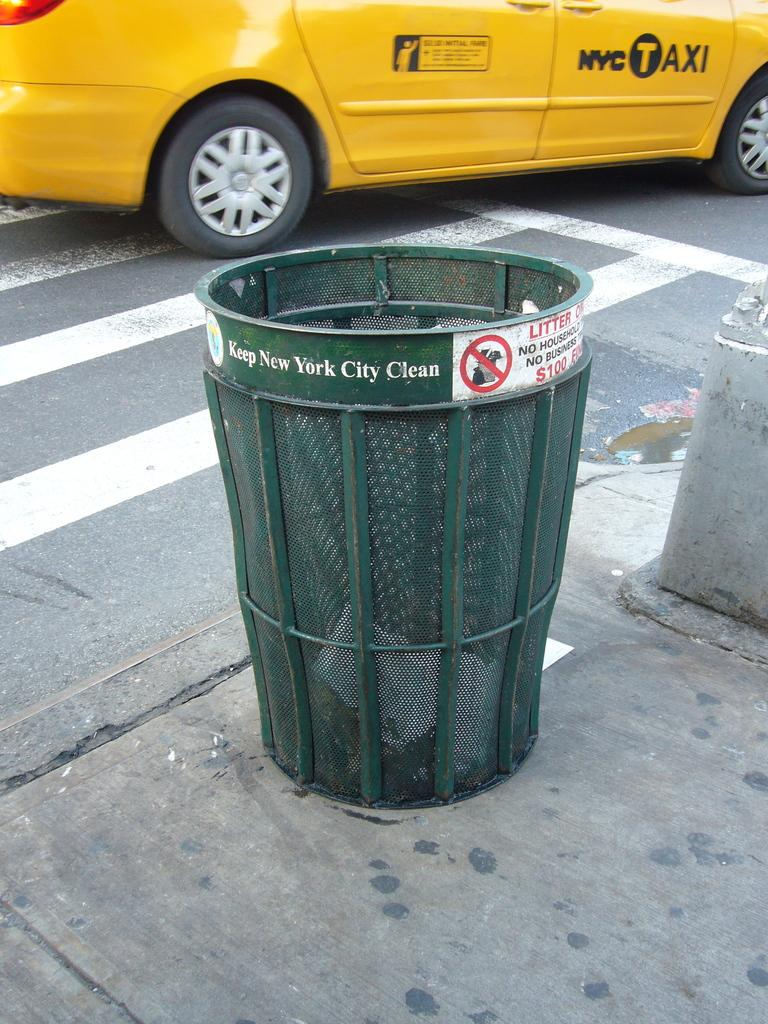<image>
Give a short and clear explanation of the subsequent image. A trash can tells people to keep New York City clean. 